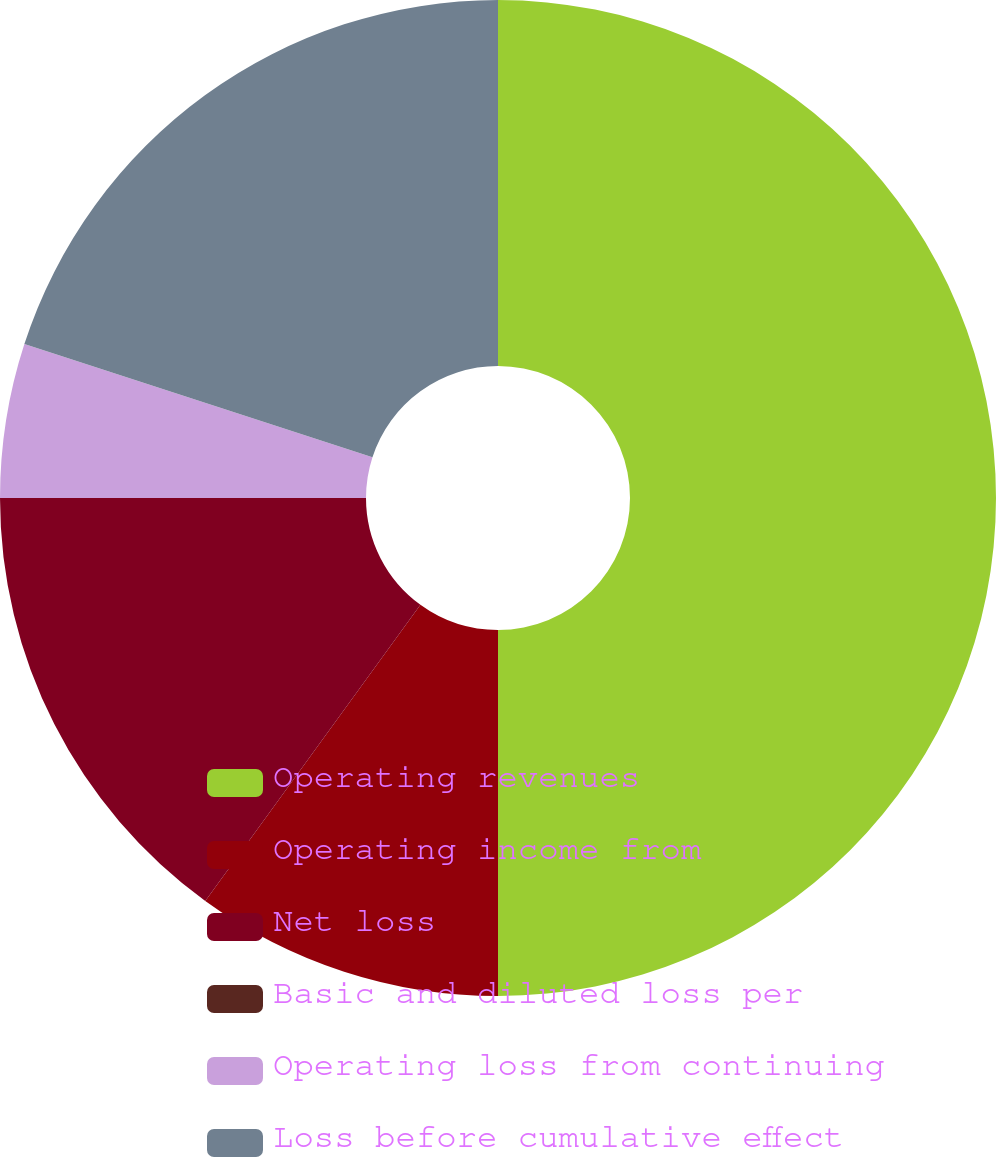<chart> <loc_0><loc_0><loc_500><loc_500><pie_chart><fcel>Operating revenues<fcel>Operating income from<fcel>Net loss<fcel>Basic and diluted loss per<fcel>Operating loss from continuing<fcel>Loss before cumulative effect<nl><fcel>50.0%<fcel>10.0%<fcel>15.0%<fcel>0.0%<fcel>5.0%<fcel>20.0%<nl></chart> 